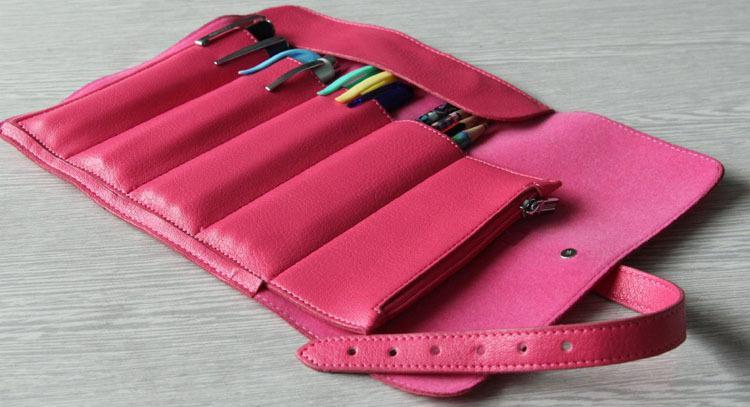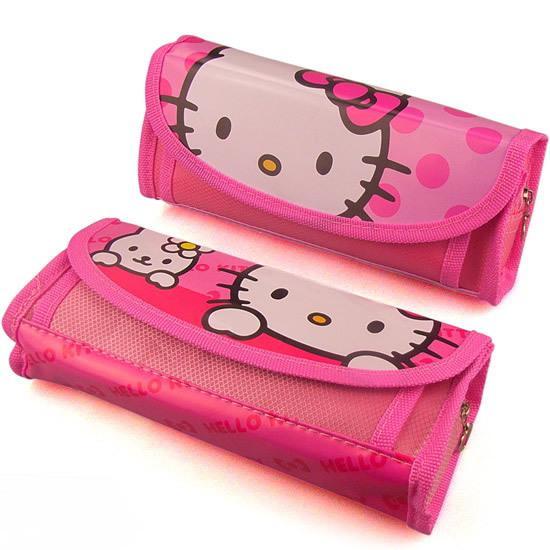The first image is the image on the left, the second image is the image on the right. For the images shown, is this caption "Two pink pencil cases sit next to each other in the image on the right." true? Answer yes or no. Yes. The first image is the image on the left, the second image is the image on the right. Given the left and right images, does the statement "One image includes an opened pink case filled with writing implements." hold true? Answer yes or no. Yes. 